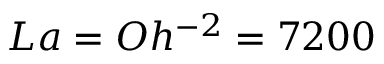<formula> <loc_0><loc_0><loc_500><loc_500>L a = O h ^ { - 2 } = 7 2 0 0</formula> 